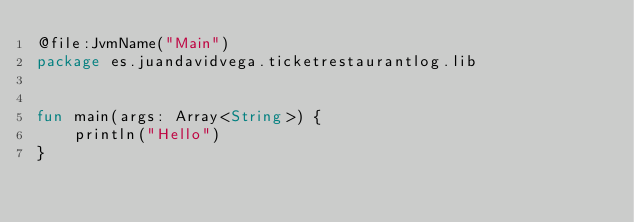<code> <loc_0><loc_0><loc_500><loc_500><_Kotlin_>@file:JvmName("Main")
package es.juandavidvega.ticketrestaurantlog.lib


fun main(args: Array<String>) {
    println("Hello")
}</code> 